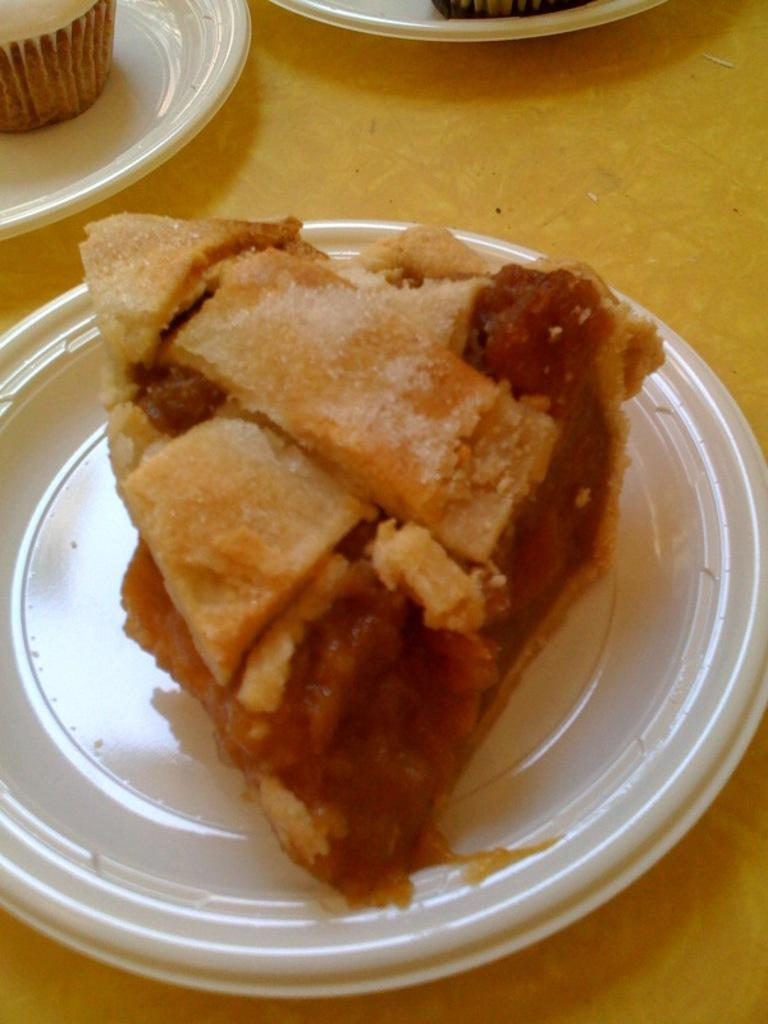Where was the image taken? The image was taken indoors. What piece of furniture can be seen in the image? There is a table in the image. What is on the table in the image? There are plates of food on the table. How many apples are on the table in the image? There is no mention of apples in the image, so we cannot determine the number of apples present. 